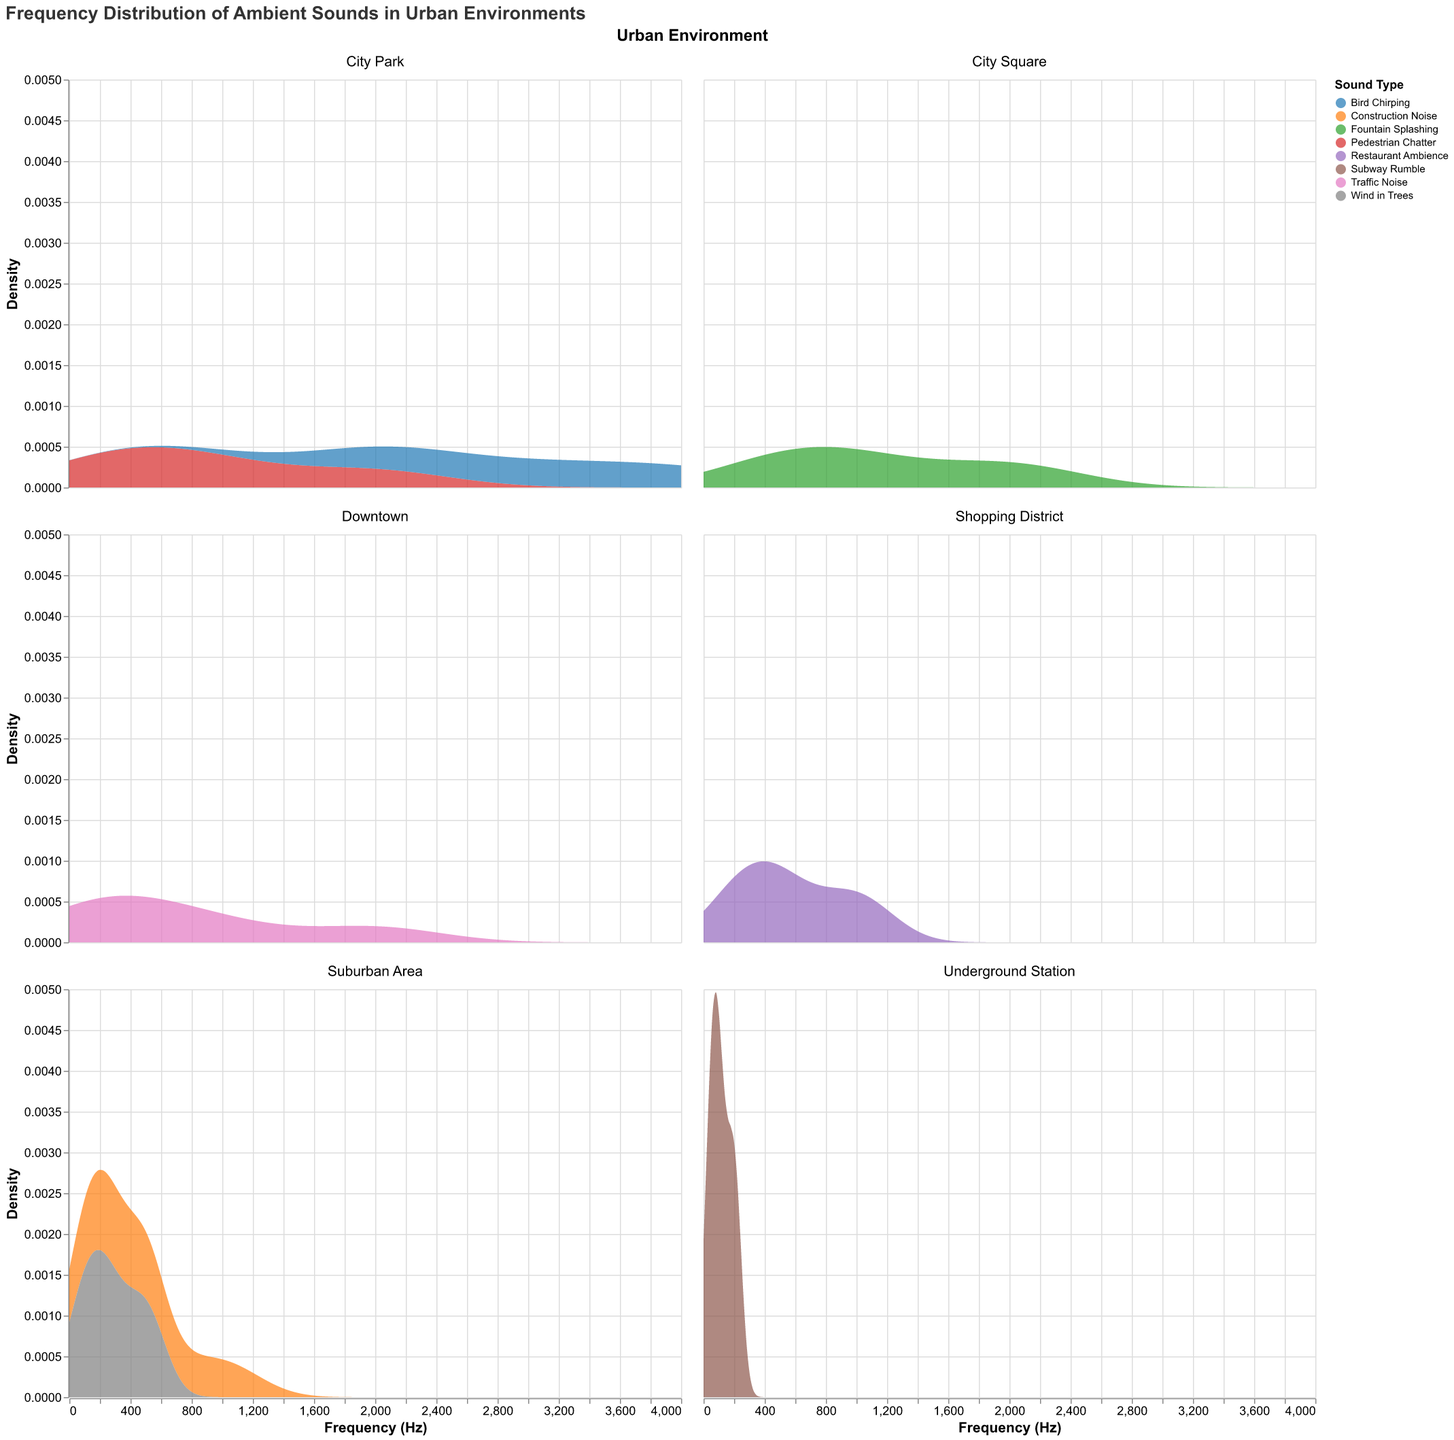What is the title of the figure? The title can be found at the top of the figure, which is a text indicating the subject of the plot.
Answer: Frequency Distribution of Ambient Sounds in Urban Environments Which sound type has the highest frequency in the City Park environment? By looking at the City Park facet, the sound type with the highest frequency at 4000 Hz can be identified, which is indicated by the Bird Chirping color.
Answer: Bird Chirping Between Traffic Noise and Subway Rumble, which sound type has a broader range of frequencies in its environment? By comparing the range of frequency values, Traffic Noise in Downtown (100-2000 Hz) spans a broader range than Subway Rumble in Underground Station (50-200 Hz).
Answer: Traffic Noise How many sound types are present in the Suburban Area environment? The Suburban Area facet shows distinct colors corresponding to sound types, each representing a unique sound (Construction Noise, Wind in Trees).
Answer: 2 Which environment shows the highest density of sounds around 500 Hz? By examining the peaks around 500 Hz in the density plots of all environments, the Suburban Area shows multiple sound types with high densities.
Answer: Suburban Area In the Shopping District environment, what is the range of frequencies for Restaurant Ambience? The frequencies for Restaurant Ambience can be identified by its color band in the Shopping District from 250 Hz to 1000 Hz.
Answer: 250 to 1000 Hz Which environment has the narrowest range of frequencies for its sound types? Comparing all environments’ frequency ranges, Underground Station (Subway Rumble, 50-200 Hz) has the narrowest range.
Answer: Underground Station Compare the density peaks of Fountain Splashing and Pedestrian Chatter. Which sound type has a higher density peak? By examining the density peaks in their respective environments (City Square for Fountain Splashing and City Park for Pedestrian Chatter), Pedestrian Chatter tends to have higher peaks.
Answer: Pedestrian Chatter Is there any overlap between the frequency ranges of Bird Chirping and Traffic Noise? Bird Chirping occurs in City Park; Traffic Noise in Downtown. By studying their frequency ranges (Bird Chirping: 2000-4000 Hz, Traffic Noise: 100-2000 Hz), there's an overlap at 2000 Hz.
Answer: Yes, at 2000 Hz 